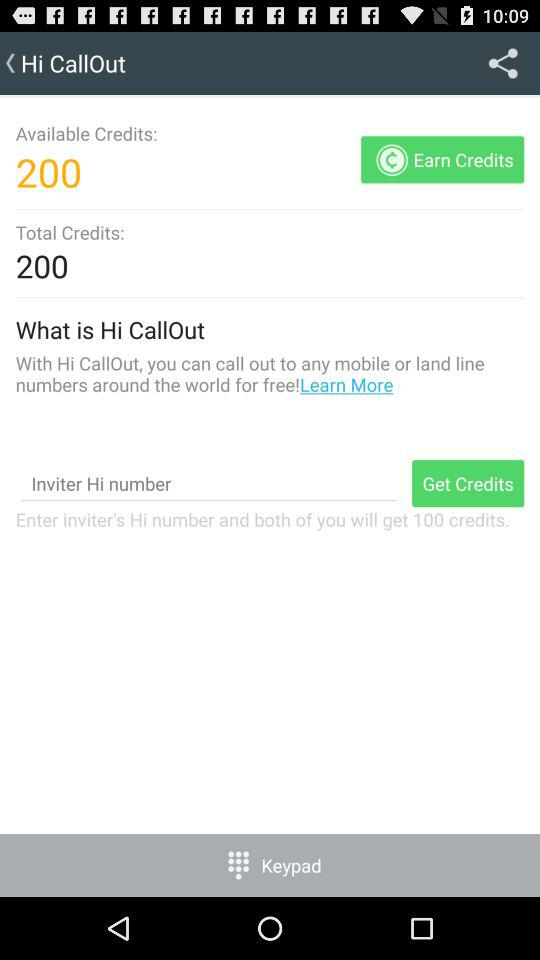How many credits do I need to earn to get to 300 credits?
Answer the question using a single word or phrase. 100 